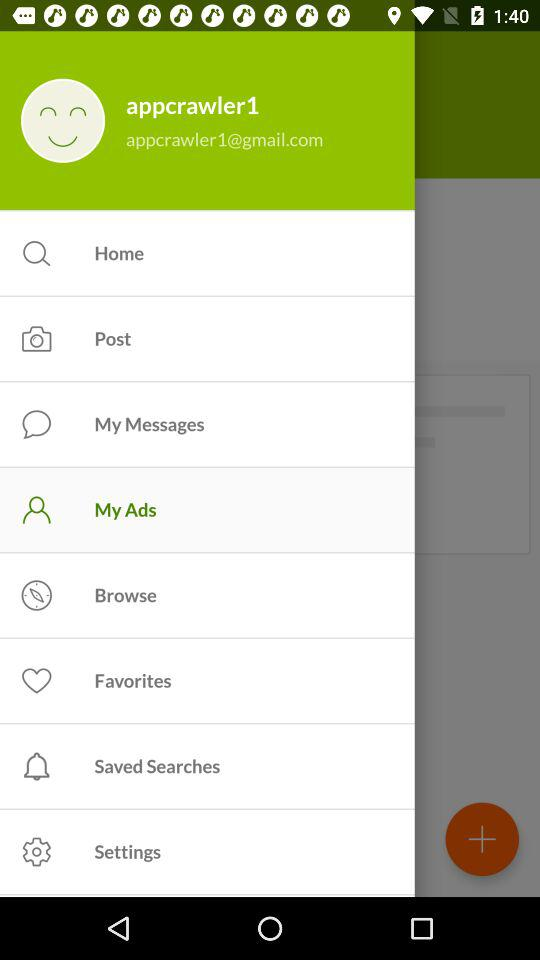What is the email address? The email address is appcrawler1@gmail.com. 